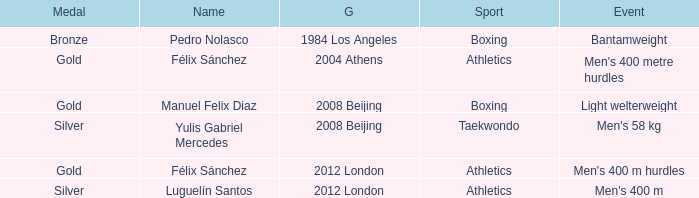Which Medal had a Name of félix sánchez, and a Games of 2012 london? Gold. 